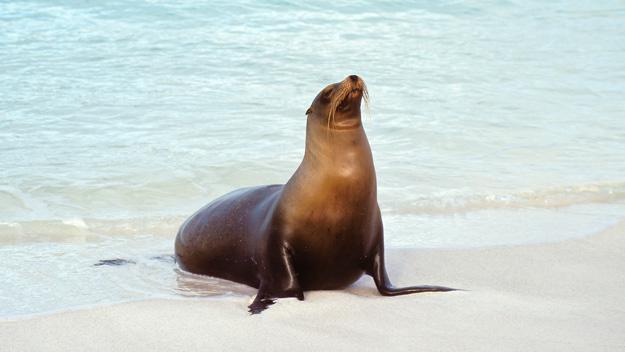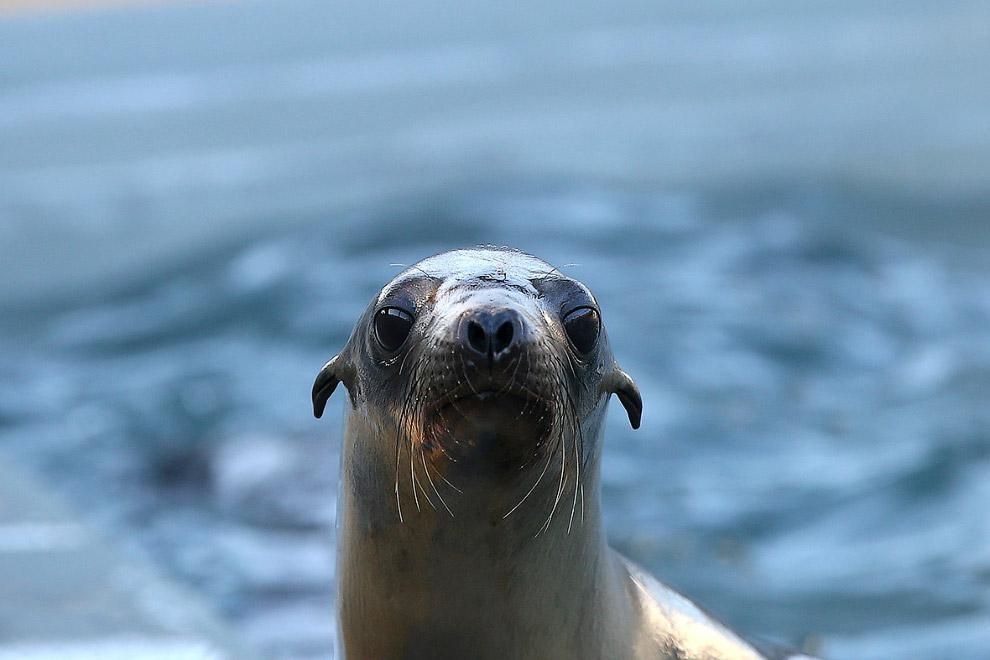The first image is the image on the left, the second image is the image on the right. Given the left and right images, does the statement "The right image shows just one young seal looking forward." hold true? Answer yes or no. Yes. 